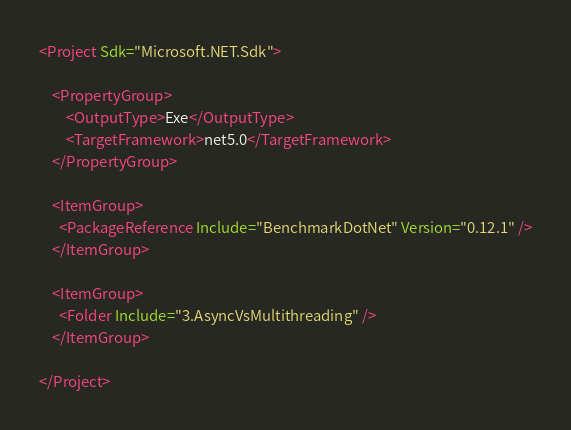Convert code to text. <code><loc_0><loc_0><loc_500><loc_500><_XML_><Project Sdk="Microsoft.NET.Sdk">

    <PropertyGroup>
        <OutputType>Exe</OutputType>
        <TargetFramework>net5.0</TargetFramework>
    </PropertyGroup>

    <ItemGroup>
      <PackageReference Include="BenchmarkDotNet" Version="0.12.1" />
    </ItemGroup>

    <ItemGroup>
      <Folder Include="3.AsyncVsMultithreading" />
    </ItemGroup>

</Project>
</code> 